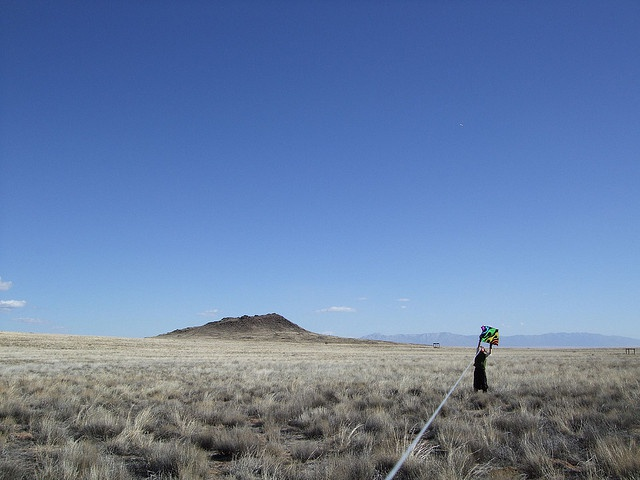Describe the objects in this image and their specific colors. I can see people in blue, black, darkgray, gray, and darkgreen tones and kite in blue, black, olive, green, and lightgreen tones in this image. 